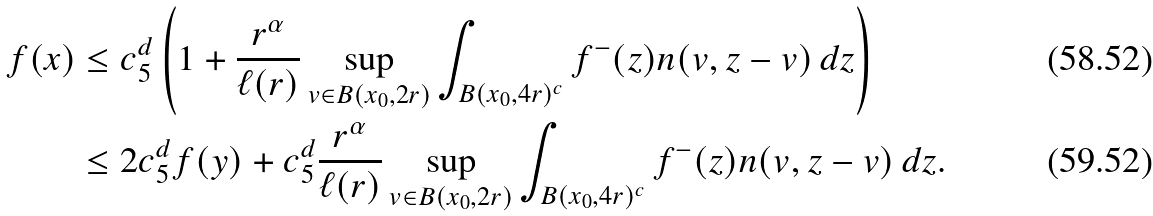Convert formula to latex. <formula><loc_0><loc_0><loc_500><loc_500>f ( x ) & \leq c _ { 5 } ^ { d } \left ( 1 + \frac { r ^ { \alpha } } { \ell ( r ) } \sup _ { v \in B ( x _ { 0 } , 2 r ) } \int _ { B ( x _ { 0 } , 4 r ) ^ { c } } f ^ { - } ( z ) n ( v , z - v ) \, d z \right ) \\ & \leq 2 c _ { 5 } ^ { d } f ( y ) + c _ { 5 } ^ { d } \frac { r ^ { \alpha } } { \ell ( r ) } \sup _ { v \in B ( x _ { 0 } , 2 r ) } \int _ { B ( x _ { 0 } , 4 r ) ^ { c } } f ^ { - } ( z ) n ( v , z - v ) \, d z .</formula> 